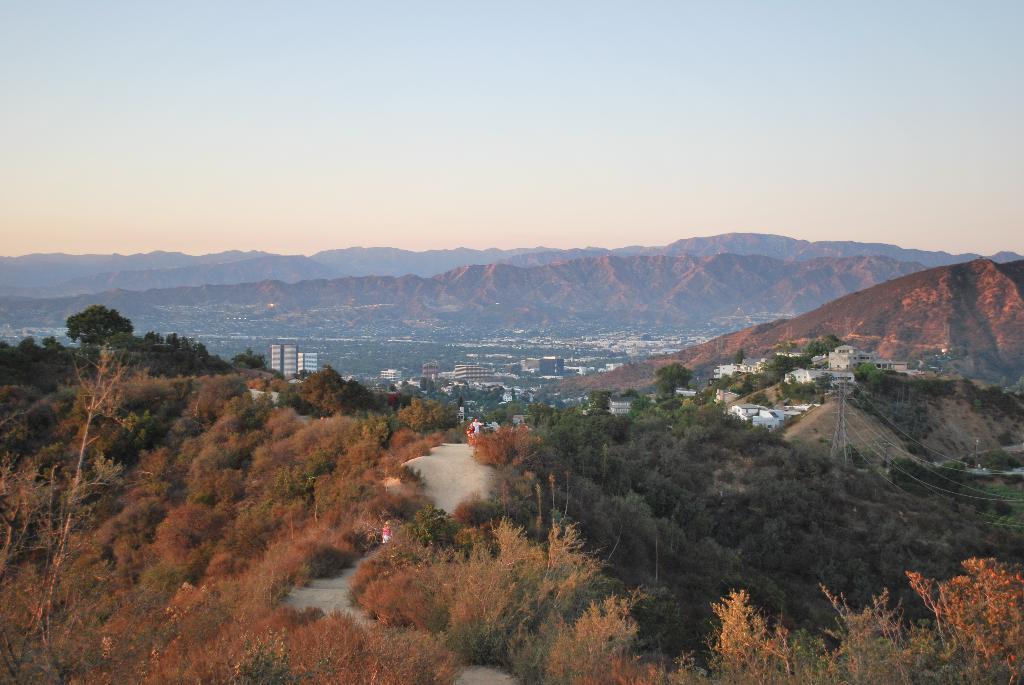Please provide a concise description of this image. This image is taken outdoors. At the top of the image there is the sky with clouds. In the background there are a few hills. At the bottom of the image there are many trees and plants on the ground. There is a tower with a few wires. In the middle of the image there are many buildings and houses on the ground. 